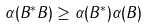Convert formula to latex. <formula><loc_0><loc_0><loc_500><loc_500>\alpha ( B ^ { * } B ) \geq \alpha ( B ^ { * } ) \alpha ( B )</formula> 